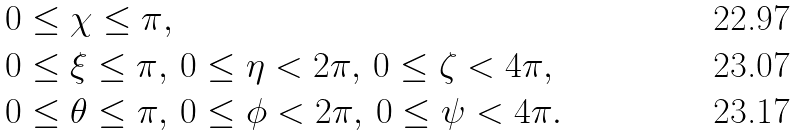<formula> <loc_0><loc_0><loc_500><loc_500>& 0 \leq \chi \leq \pi , \\ & 0 \leq \xi \leq \pi , \, 0 \leq \eta < 2 \pi , \, 0 \leq \zeta < 4 \pi , \\ & 0 \leq \theta \leq \pi , \, 0 \leq \phi < 2 \pi , \, 0 \leq \psi < 4 \pi .</formula> 